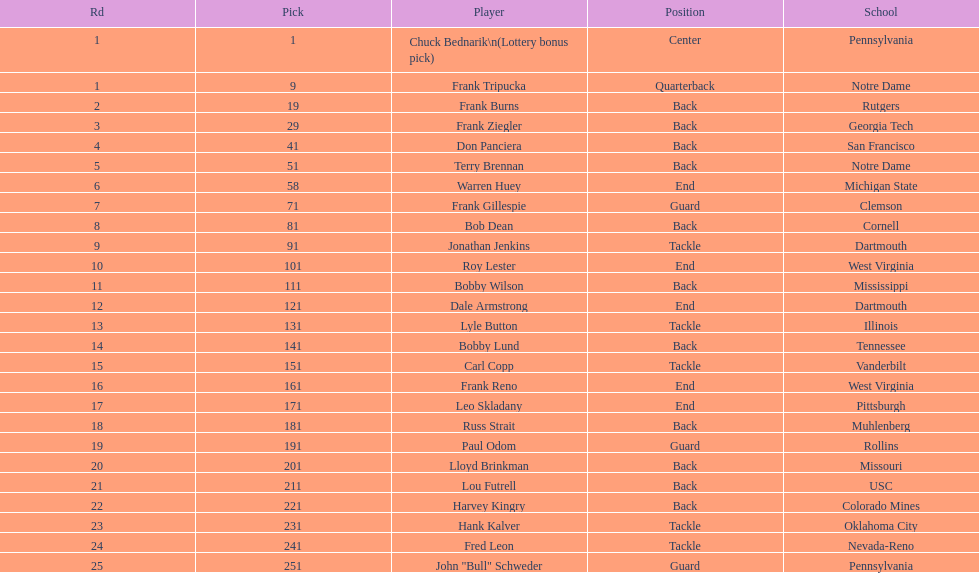How many individuals from notre dame were players? 2. 